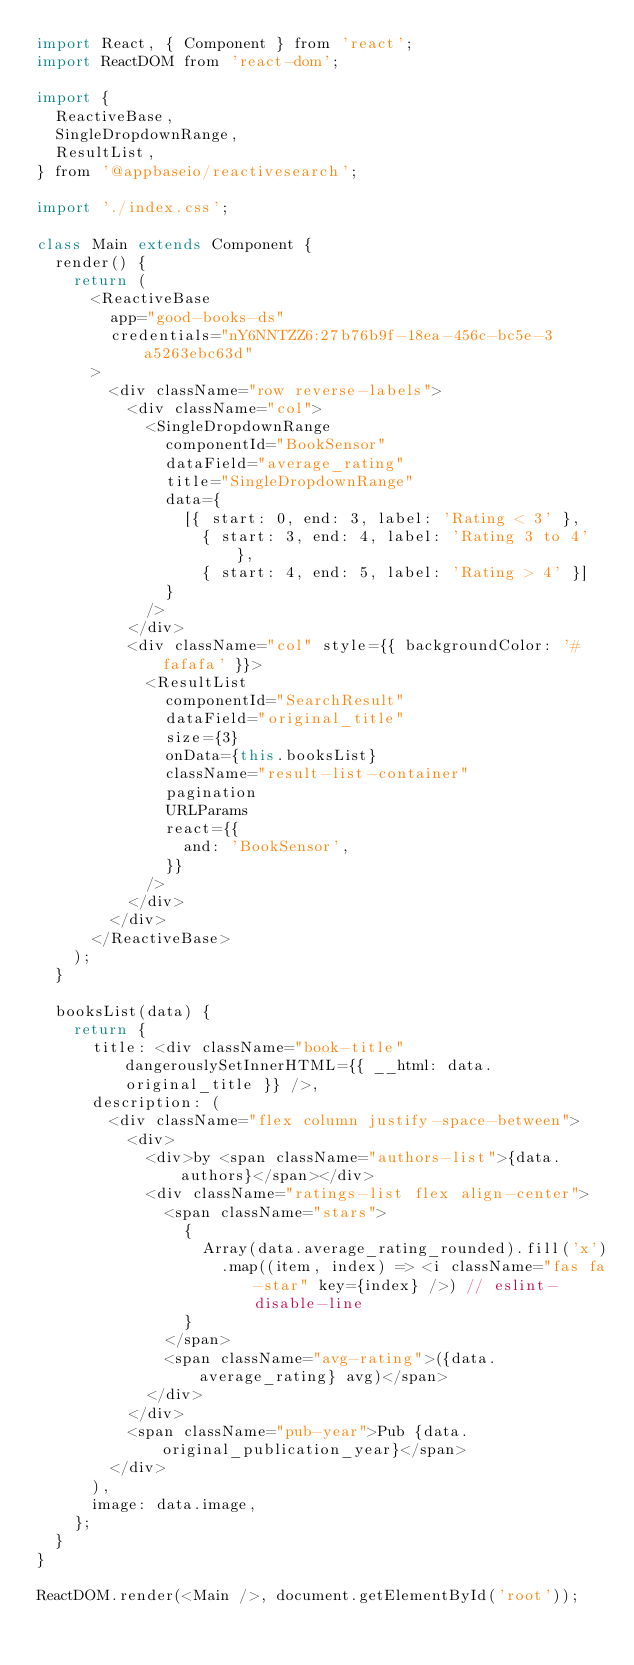<code> <loc_0><loc_0><loc_500><loc_500><_JavaScript_>import React, { Component } from 'react';
import ReactDOM from 'react-dom';

import {
	ReactiveBase,
	SingleDropdownRange,
	ResultList,
} from '@appbaseio/reactivesearch';

import './index.css';

class Main extends Component {
	render() {
		return (
			<ReactiveBase
				app="good-books-ds"
				credentials="nY6NNTZZ6:27b76b9f-18ea-456c-bc5e-3a5263ebc63d"
			>
				<div className="row reverse-labels">
					<div className="col">
						<SingleDropdownRange
							componentId="BookSensor"
							dataField="average_rating"
							title="SingleDropdownRange"
							data={
								[{ start: 0, end: 3, label: 'Rating < 3' },
									{ start: 3, end: 4, label: 'Rating 3 to 4' },
									{ start: 4, end: 5, label: 'Rating > 4' }]
							}
						/>
					</div>
					<div className="col" style={{ backgroundColor: '#fafafa' }}>
						<ResultList
							componentId="SearchResult"
							dataField="original_title"
							size={3}
							onData={this.booksList}
							className="result-list-container"
							pagination
							URLParams
							react={{
								and: 'BookSensor',
							}}
						/>
					</div>
				</div>
			</ReactiveBase>
		);
	}

	booksList(data) {
		return {
			title: <div className="book-title" dangerouslySetInnerHTML={{ __html: data.original_title }} />,
			description: (
				<div className="flex column justify-space-between">
					<div>
						<div>by <span className="authors-list">{data.authors}</span></div>
						<div className="ratings-list flex align-center">
							<span className="stars">
								{
									Array(data.average_rating_rounded).fill('x')
										.map((item, index) => <i className="fas fa-star" key={index} />) // eslint-disable-line
								}
							</span>
							<span className="avg-rating">({data.average_rating} avg)</span>
						</div>
					</div>
					<span className="pub-year">Pub {data.original_publication_year}</span>
				</div>
			),
			image: data.image,
		};
	}
}

ReactDOM.render(<Main />, document.getElementById('root'));
</code> 